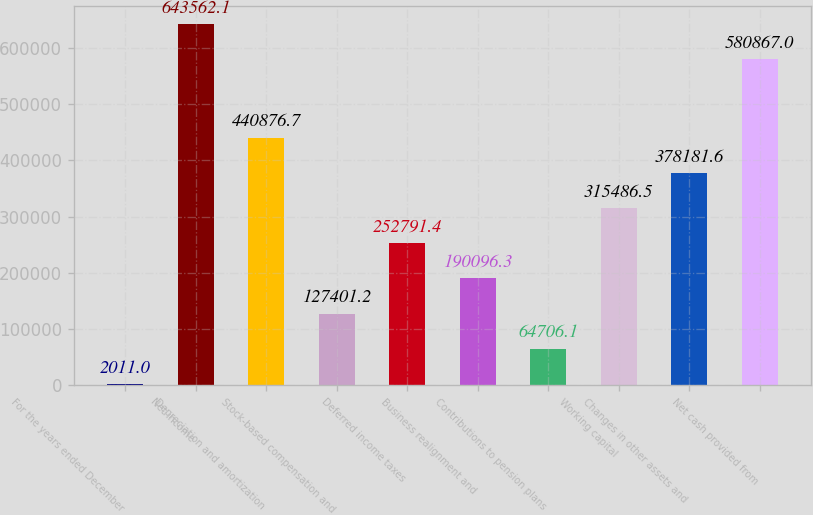Convert chart to OTSL. <chart><loc_0><loc_0><loc_500><loc_500><bar_chart><fcel>For the years ended December<fcel>Net income<fcel>Depreciation and amortization<fcel>Stock-based compensation and<fcel>Deferred income taxes<fcel>Business realignment and<fcel>Contributions to pension plans<fcel>Working capital<fcel>Changes in other assets and<fcel>Net cash provided from<nl><fcel>2011<fcel>643562<fcel>440877<fcel>127401<fcel>252791<fcel>190096<fcel>64706.1<fcel>315486<fcel>378182<fcel>580867<nl></chart> 